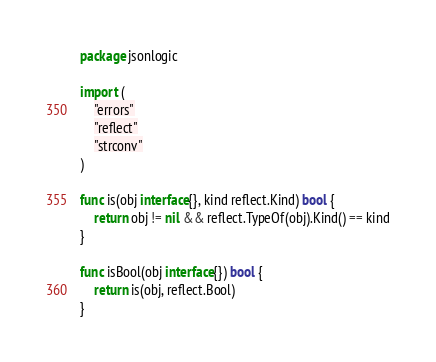<code> <loc_0><loc_0><loc_500><loc_500><_Go_>package jsonlogic

import (
	"errors"
	"reflect"
	"strconv"
)

func is(obj interface{}, kind reflect.Kind) bool {
	return obj != nil && reflect.TypeOf(obj).Kind() == kind
}

func isBool(obj interface{}) bool {
	return is(obj, reflect.Bool)
}
</code> 